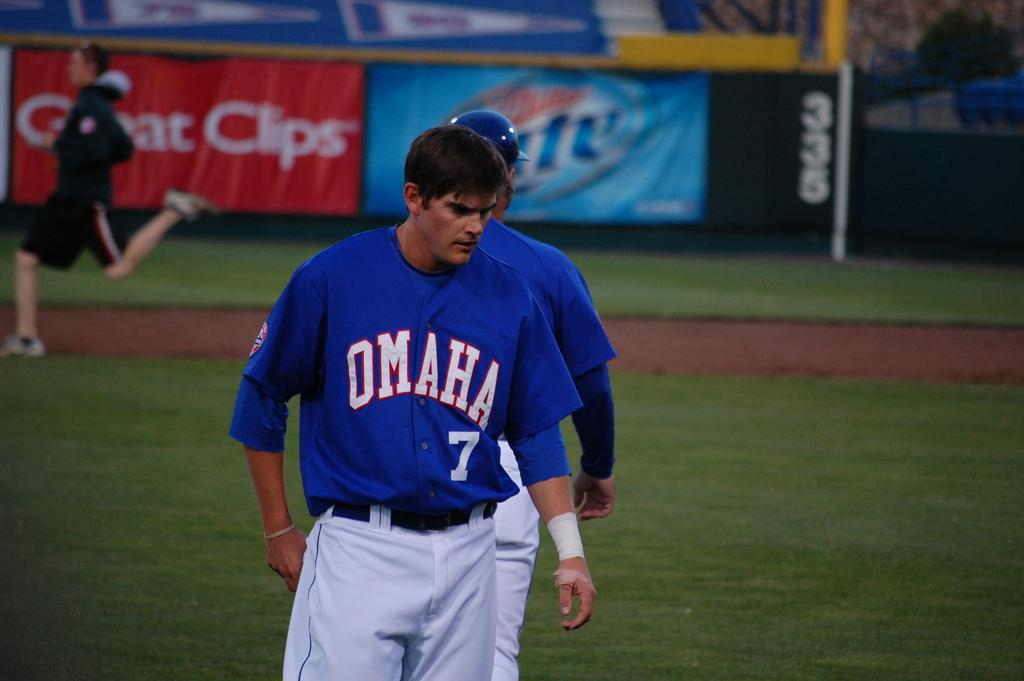<image>
Summarize the visual content of the image. A baseball player wears a blue Omaha uniform with the number 7 on it. 